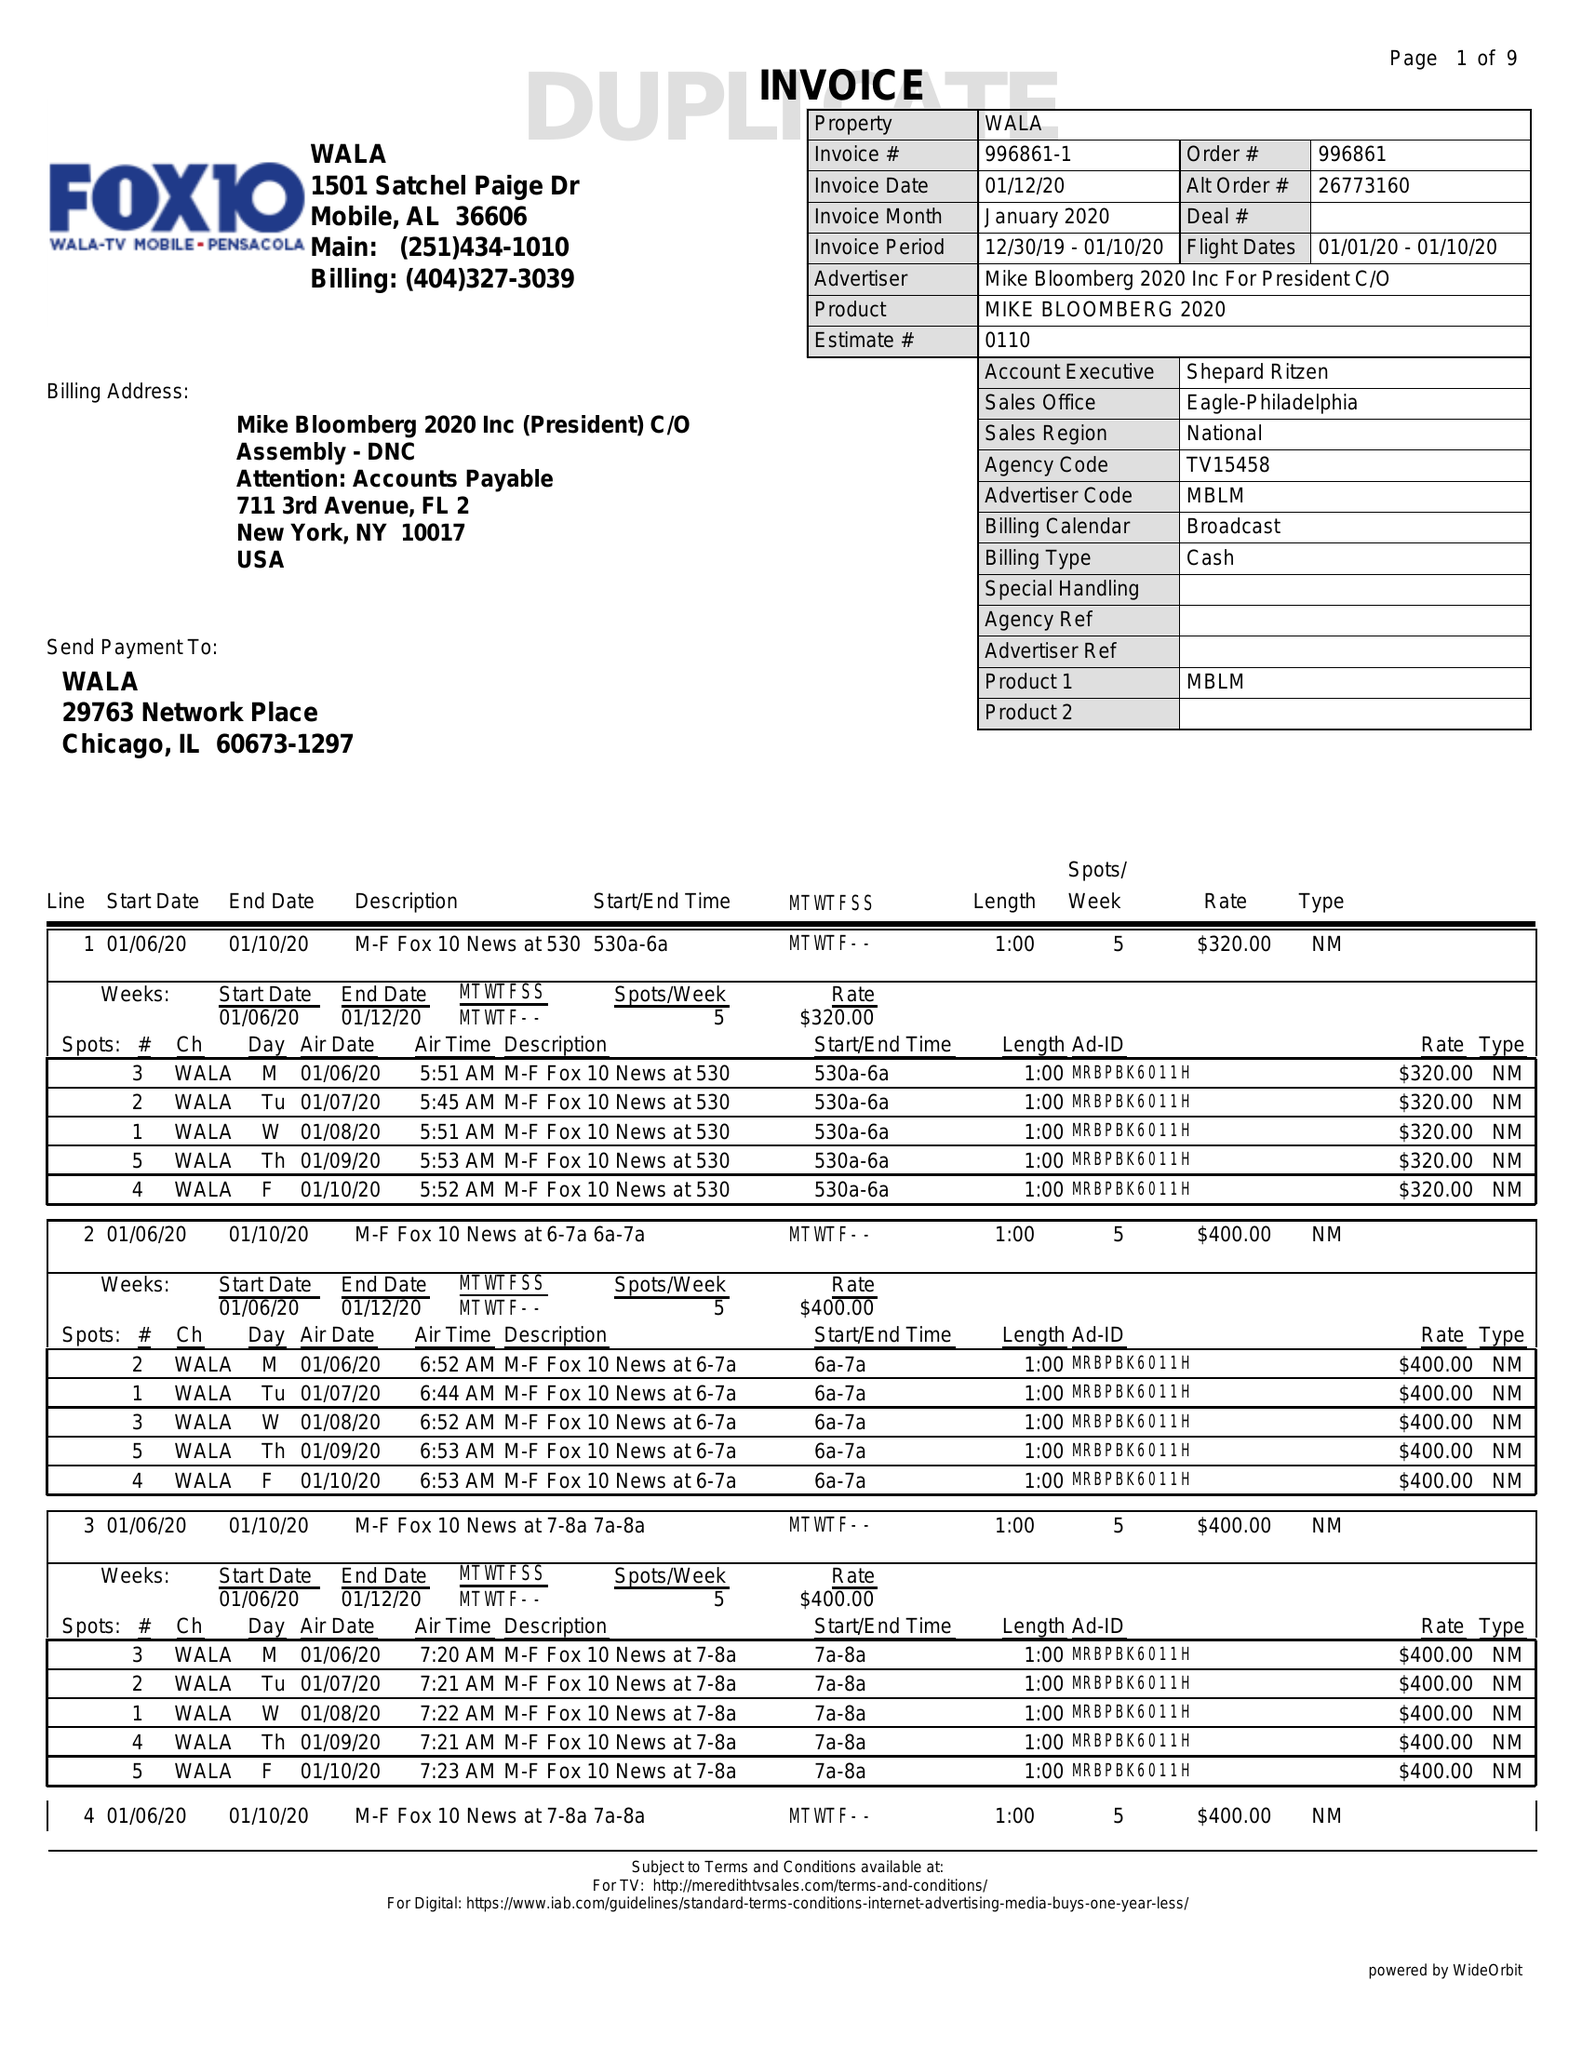What is the value for the flight_to?
Answer the question using a single word or phrase. 01/10/20 